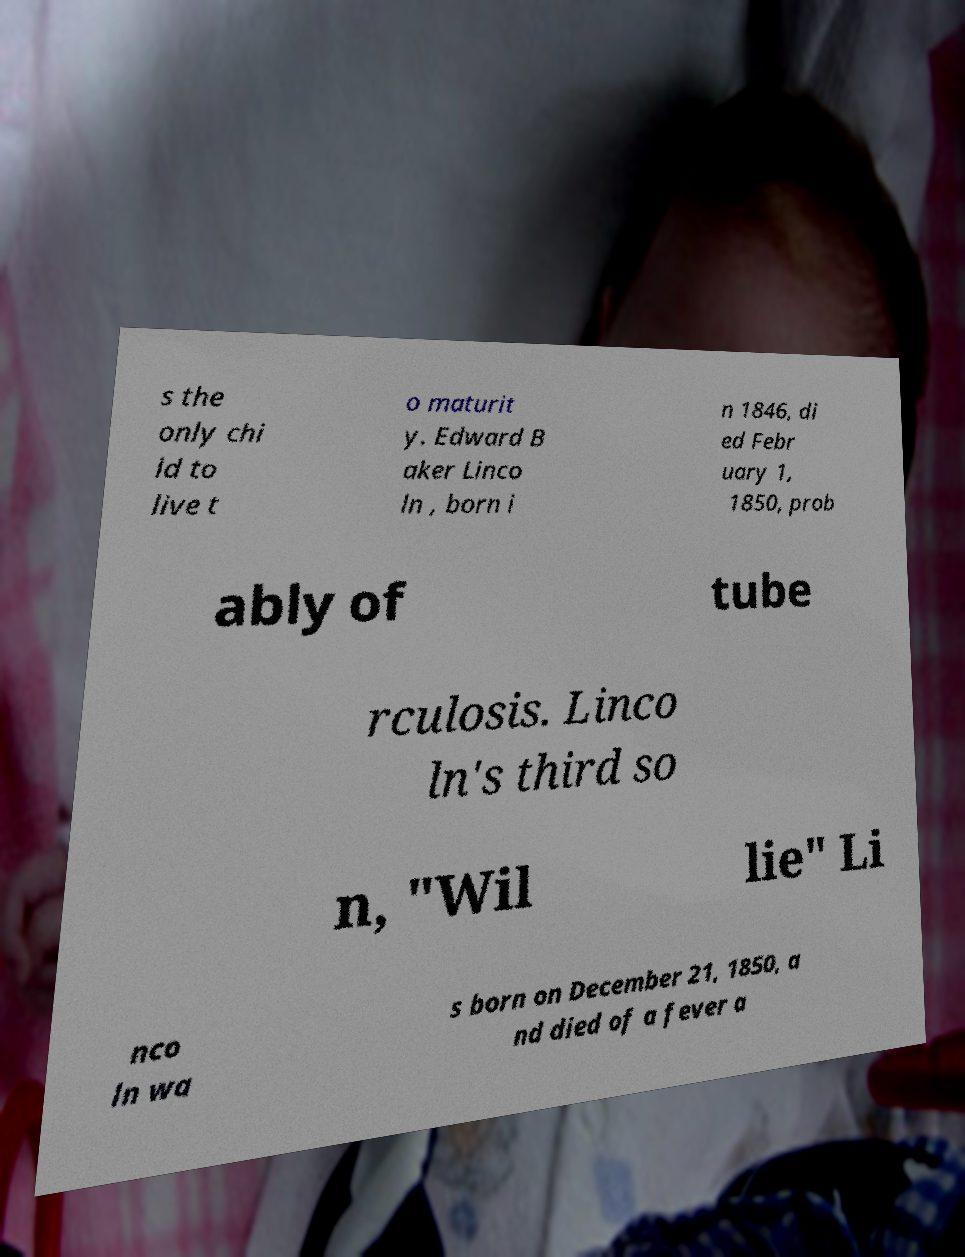I need the written content from this picture converted into text. Can you do that? s the only chi ld to live t o maturit y. Edward B aker Linco ln , born i n 1846, di ed Febr uary 1, 1850, prob ably of tube rculosis. Linco ln's third so n, "Wil lie" Li nco ln wa s born on December 21, 1850, a nd died of a fever a 